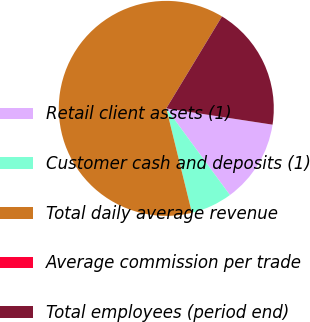Convert chart. <chart><loc_0><loc_0><loc_500><loc_500><pie_chart><fcel>Retail client assets (1)<fcel>Customer cash and deposits (1)<fcel>Total daily average revenue<fcel>Average commission per trade<fcel>Total employees (period end)<nl><fcel>12.5%<fcel>6.25%<fcel>62.49%<fcel>0.0%<fcel>18.75%<nl></chart> 